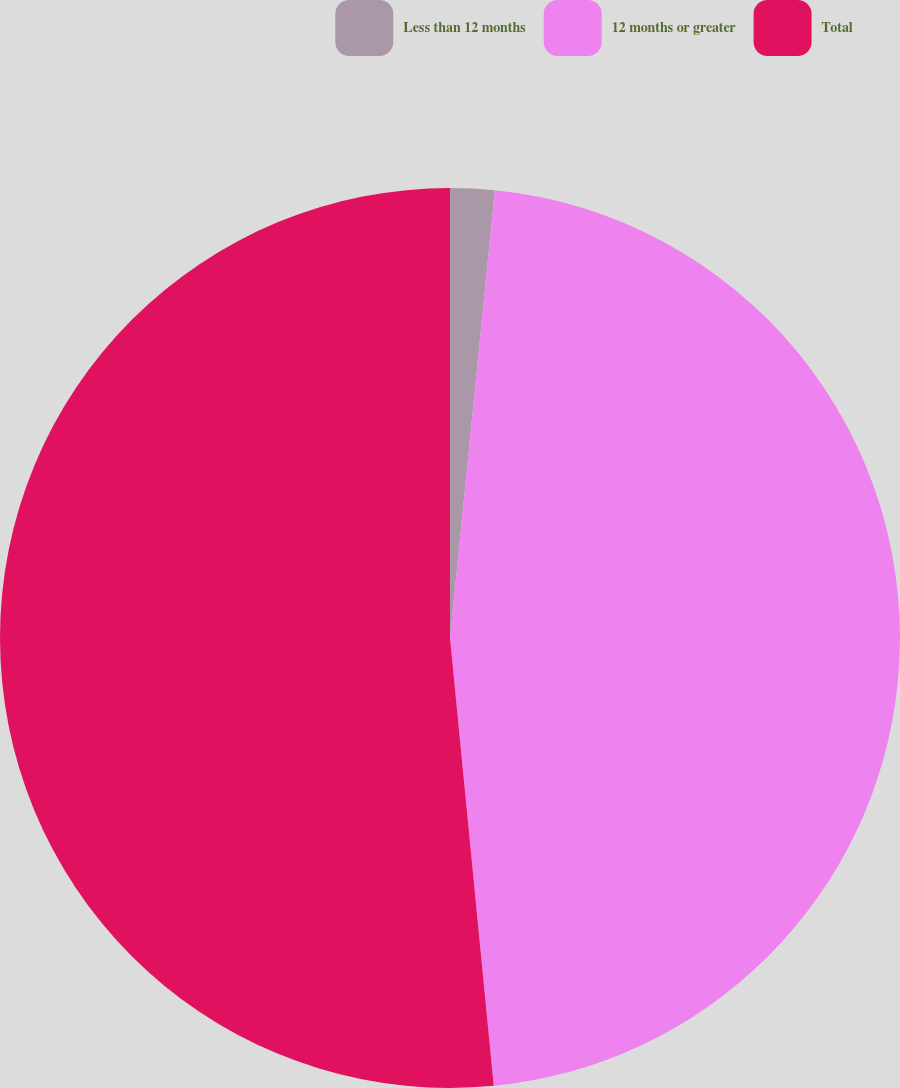Convert chart to OTSL. <chart><loc_0><loc_0><loc_500><loc_500><pie_chart><fcel>Less than 12 months<fcel>12 months or greater<fcel>Total<nl><fcel>1.59%<fcel>46.86%<fcel>51.55%<nl></chart> 